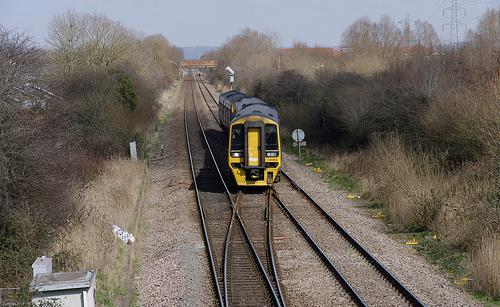Question: what is the train doing?
Choices:
A. Picking up passengers.
B. Switching tracks.
C. Hauling cars.
D. Riding to the train station.
Answer with the letter. Answer: B Question: where is there a sign?
Choices:
A. On the street corner.
B. On the right side of the track, near the train.
C. On the post.
D. On the fence.
Answer with the letter. Answer: B Question: how many tracks are there?
Choices:
A. Two.
B. Four.
C. Many.
D. Ten.
Answer with the letter. Answer: A Question: where was the train passing?
Choices:
A. Through the city.
B. The train station.
C. Through the countryside.
D. The passengers.
Answer with the letter. Answer: C 